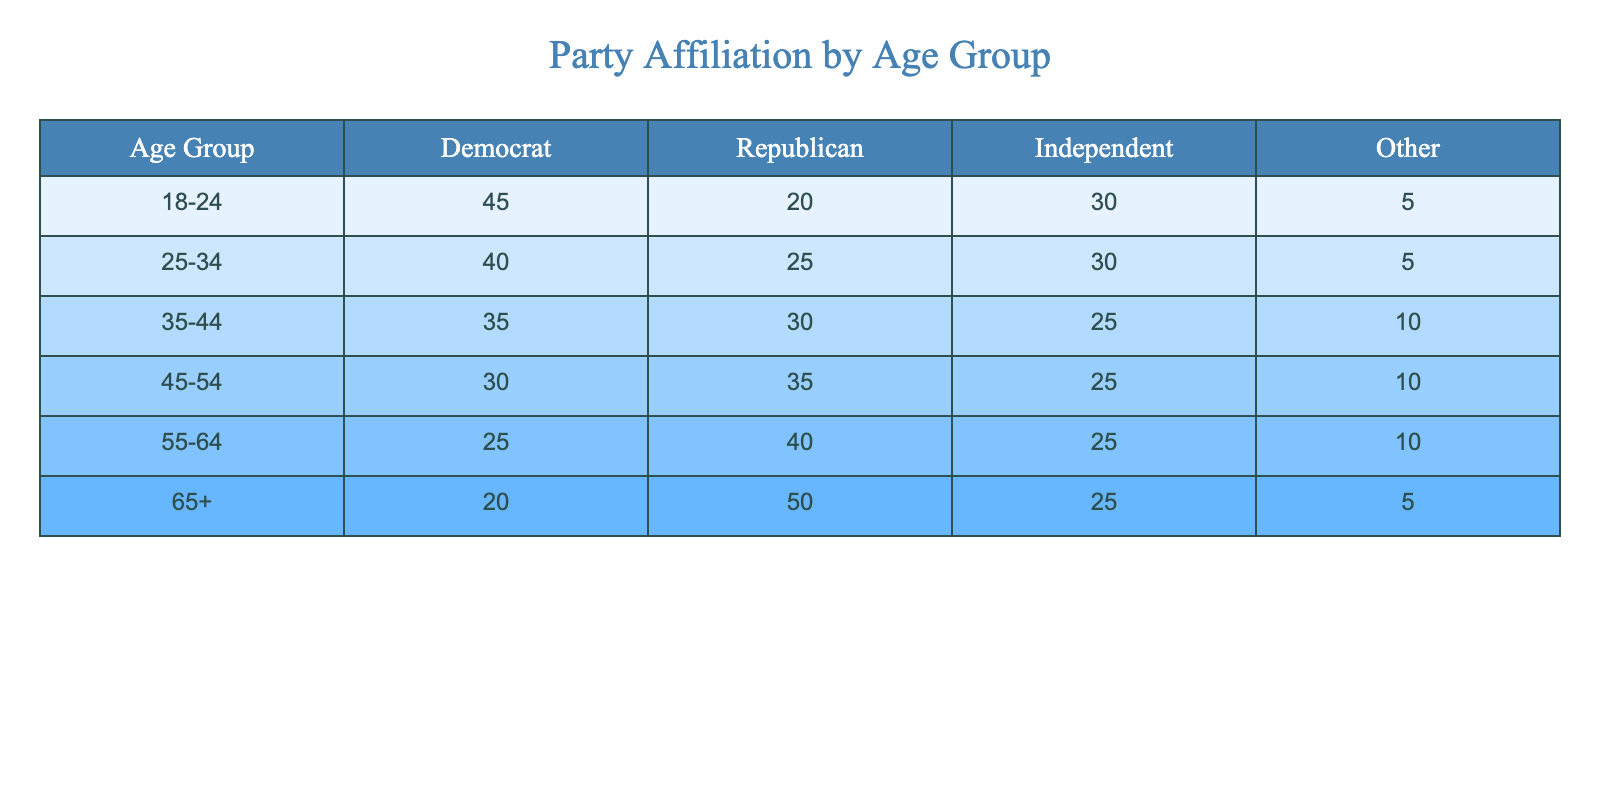What is the percentage of Republicans in the 25-34 age group? In the 25-34 age group, the number of Republicans is 25. To find the percentage, we take the total for that age group, which is 40 (Democrat) + 25 (Republican) + 30 (Independent) + 5 (Other) = 100. Therefore, the percentage of Republicans is (25/100) * 100 = 25%.
Answer: 25% Which age group has the highest percentage of Independents? Looking at the table, the Independents’ values are 30 (18-24), 30 (25-34), 25 (35-44), 25 (45-54), 25 (55-64), and 25 (65+). Both the 18-24 and 25-34 groups have 30, which is the highest.
Answer: 18-24 and 25-34 In which age group do most people identify as Democrats? The 18-24 age group has the highest number of Democrats at 45. Comparing this to other age groups, all other groups have fewer Democrats.
Answer: 18-24 What is the total number of respondents who identify as Independents across all age groups? To find the total number of Independents, we add the values for each age group: 30 (18-24) + 30 (25-34) + 25 (35-44) + 25 (45-54) + 25 (55-64) + 25 (65+) = 30 + 30 + 25 + 25 + 25 + 25 = 160.
Answer: 160 Is it true that the percentage of Democrats decreases with age? Examining the table, as the age groups increase, the number of Democrats decreases from 45 (18-24) down to 20 (65+). Thus, it is true that the percentage of Democrats decreases with age.
Answer: Yes What is the difference in the number of Republicans between the 45-54 and 55-64 age groups? In the 45-54 age group, there are 35 Republicans, while in the 55-64 age group, there are 40. The difference is calculated as 40 - 35 = 5.
Answer: 5 What age group has the lowest number of Democrats? The age group with the lowest count of Democrats is the 65+ group with 20 Democrats, which is less than any other age group listed.
Answer: 65+ What is the average number of votes for Other party affiliation across all age groups? The values for Other across the age groups are 5, 5, 10, 10, 10, and 5. To find the average, we sum these values: 5 + 5 + 10 + 10 + 10 + 5 = 55, and there are 6 groups, so the average is 55/6 = approximately 9.17.
Answer: Approximately 9.17 